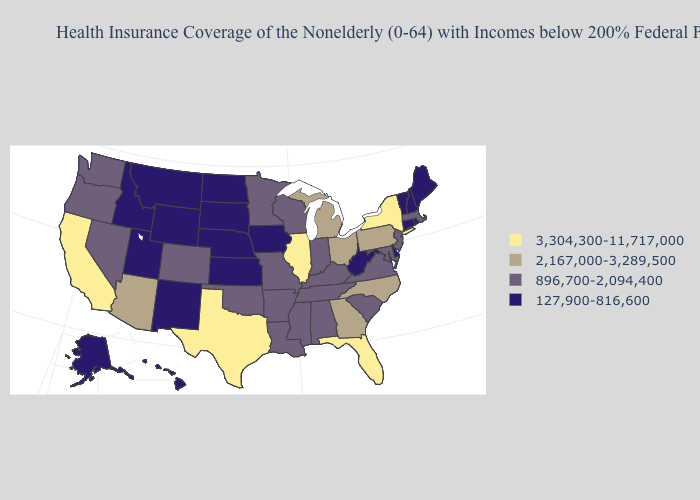Name the states that have a value in the range 127,900-816,600?
Keep it brief. Alaska, Connecticut, Delaware, Hawaii, Idaho, Iowa, Kansas, Maine, Montana, Nebraska, New Hampshire, New Mexico, North Dakota, Rhode Island, South Dakota, Utah, Vermont, West Virginia, Wyoming. Does Colorado have the lowest value in the West?
Short answer required. No. What is the lowest value in the USA?
Be succinct. 127,900-816,600. What is the value of Utah?
Quick response, please. 127,900-816,600. How many symbols are there in the legend?
Be succinct. 4. Among the states that border Missouri , does Illinois have the highest value?
Answer briefly. Yes. What is the highest value in the USA?
Be succinct. 3,304,300-11,717,000. Does Minnesota have the lowest value in the USA?
Keep it brief. No. What is the highest value in states that border Michigan?
Keep it brief. 2,167,000-3,289,500. What is the highest value in the West ?
Concise answer only. 3,304,300-11,717,000. Does the first symbol in the legend represent the smallest category?
Write a very short answer. No. What is the value of Florida?
Keep it brief. 3,304,300-11,717,000. Name the states that have a value in the range 3,304,300-11,717,000?
Write a very short answer. California, Florida, Illinois, New York, Texas. What is the value of Illinois?
Keep it brief. 3,304,300-11,717,000. How many symbols are there in the legend?
Give a very brief answer. 4. 